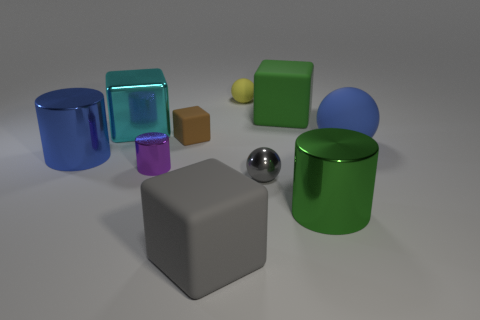Subtract all cylinders. How many objects are left? 7 Subtract 1 green cylinders. How many objects are left? 9 Subtract all large shiny things. Subtract all big rubber cubes. How many objects are left? 5 Add 2 blue spheres. How many blue spheres are left? 3 Add 5 big green rubber cylinders. How many big green rubber cylinders exist? 5 